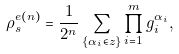Convert formula to latex. <formula><loc_0><loc_0><loc_500><loc_500>\rho _ { s } ^ { e ( n ) } = \frac { 1 } { 2 ^ { n } } \sum _ { \{ \alpha _ { i } \in z \} } \prod _ { i = 1 } ^ { m } g _ { i } ^ { \alpha _ { i } } ,</formula> 